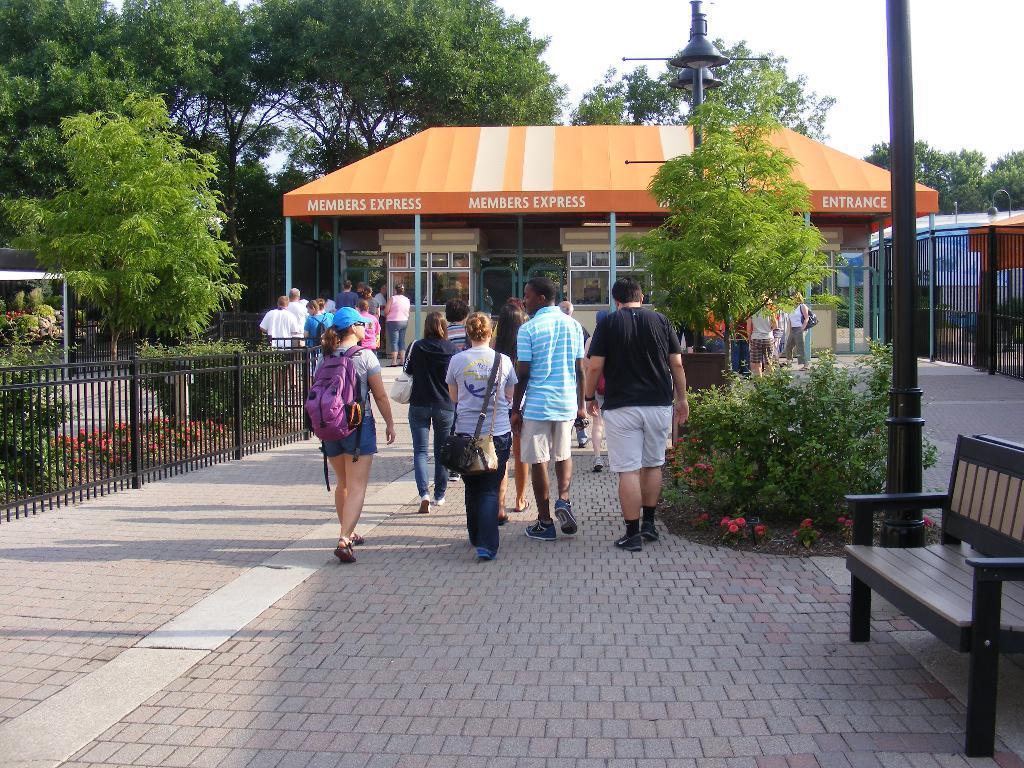Describe this image in one or two sentences. In this image there are group of people walking in the road ,and in back ground there is building, tree, plant, fence, bench , pole , sky. 